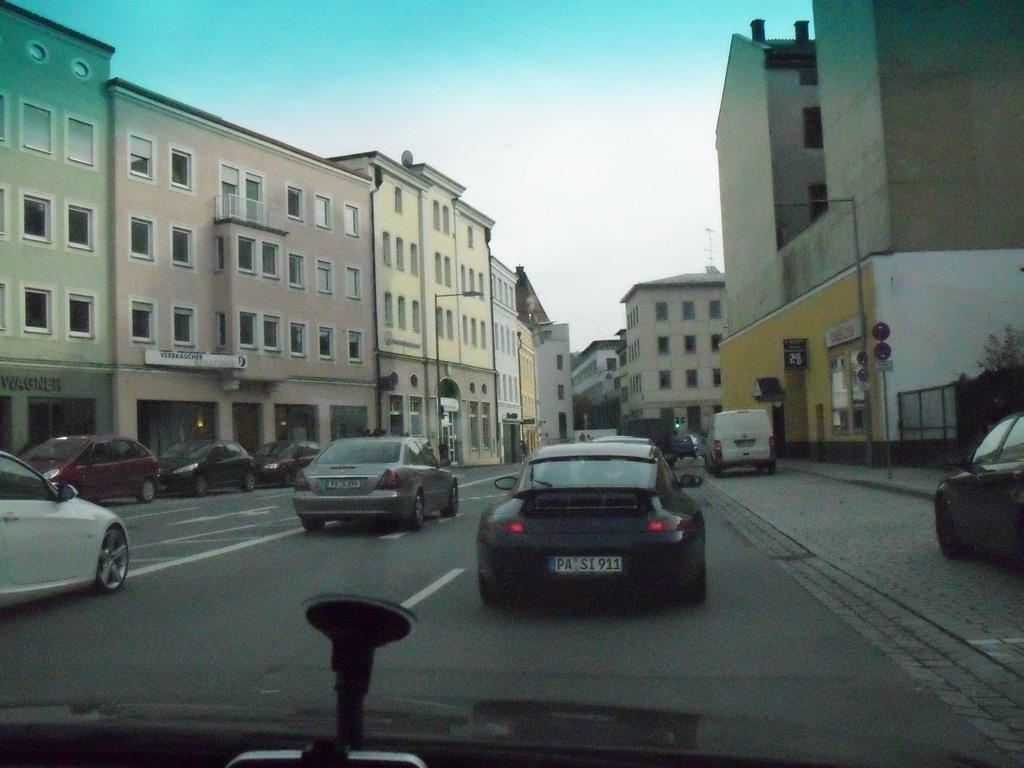What can be seen on the road in the image? There are vehicles on the road in the image. What else can be seen in the background of the image? There are buildings visible in the image. What type of natural elements are present in the image? Trees are present in the image. What might provide information or directions in the image? Sign boards are present in the image. Can you tell me how many worms are crawling on the secretary's feet in the image? There is no secretary or worms present in the image. What type of shoes is the secretary wearing in the image? There is no secretary present in the image, so it is not possible to determine the type of shoes they might be wearing. 